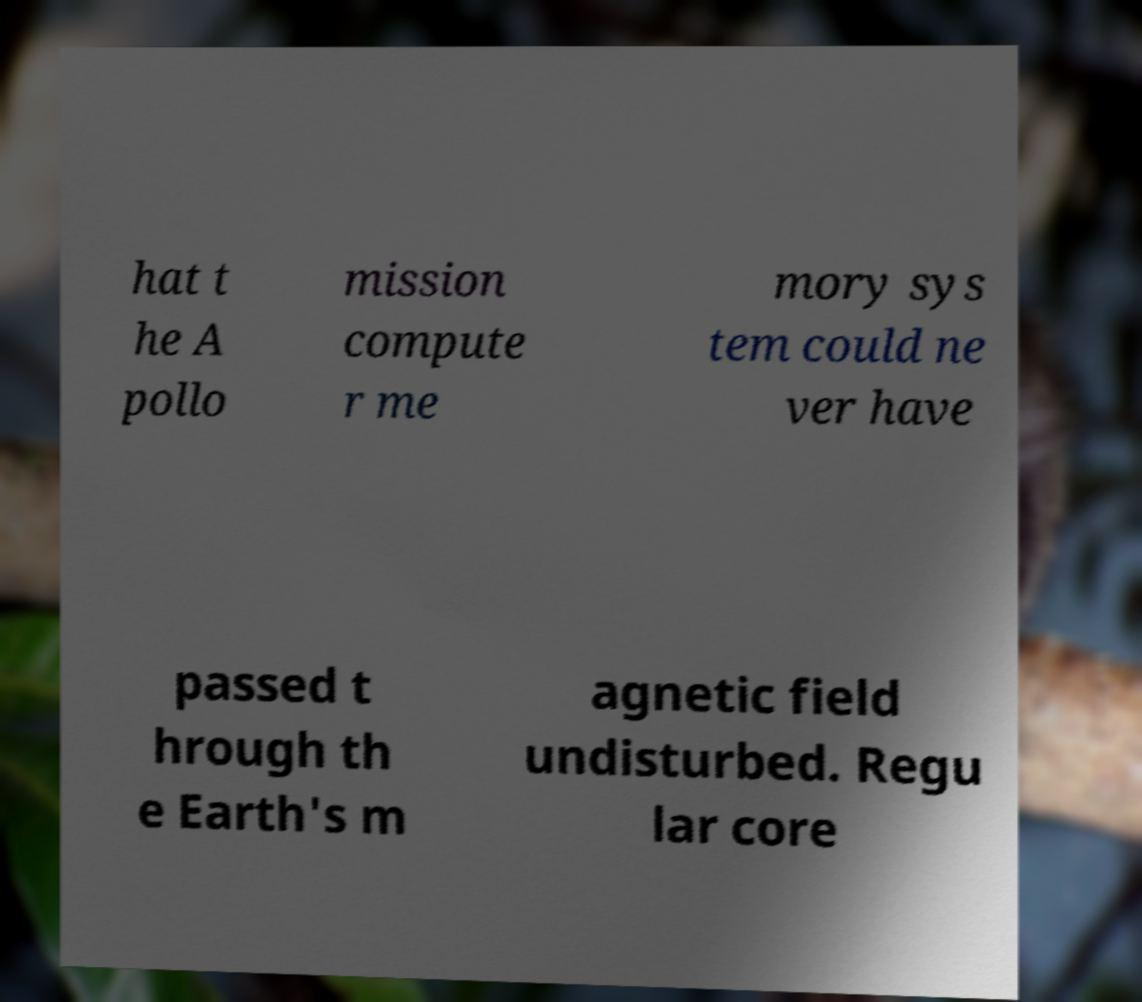There's text embedded in this image that I need extracted. Can you transcribe it verbatim? hat t he A pollo mission compute r me mory sys tem could ne ver have passed t hrough th e Earth's m agnetic field undisturbed. Regu lar core 